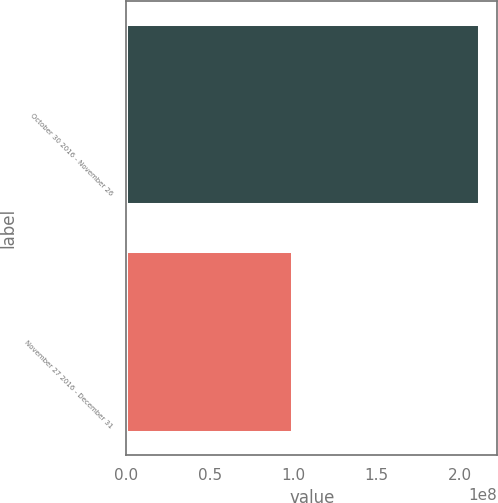<chart> <loc_0><loc_0><loc_500><loc_500><bar_chart><fcel>October 30 2016 - November 26<fcel>November 27 2016 - December 31<nl><fcel>2.1173e+08<fcel>1e+08<nl></chart> 